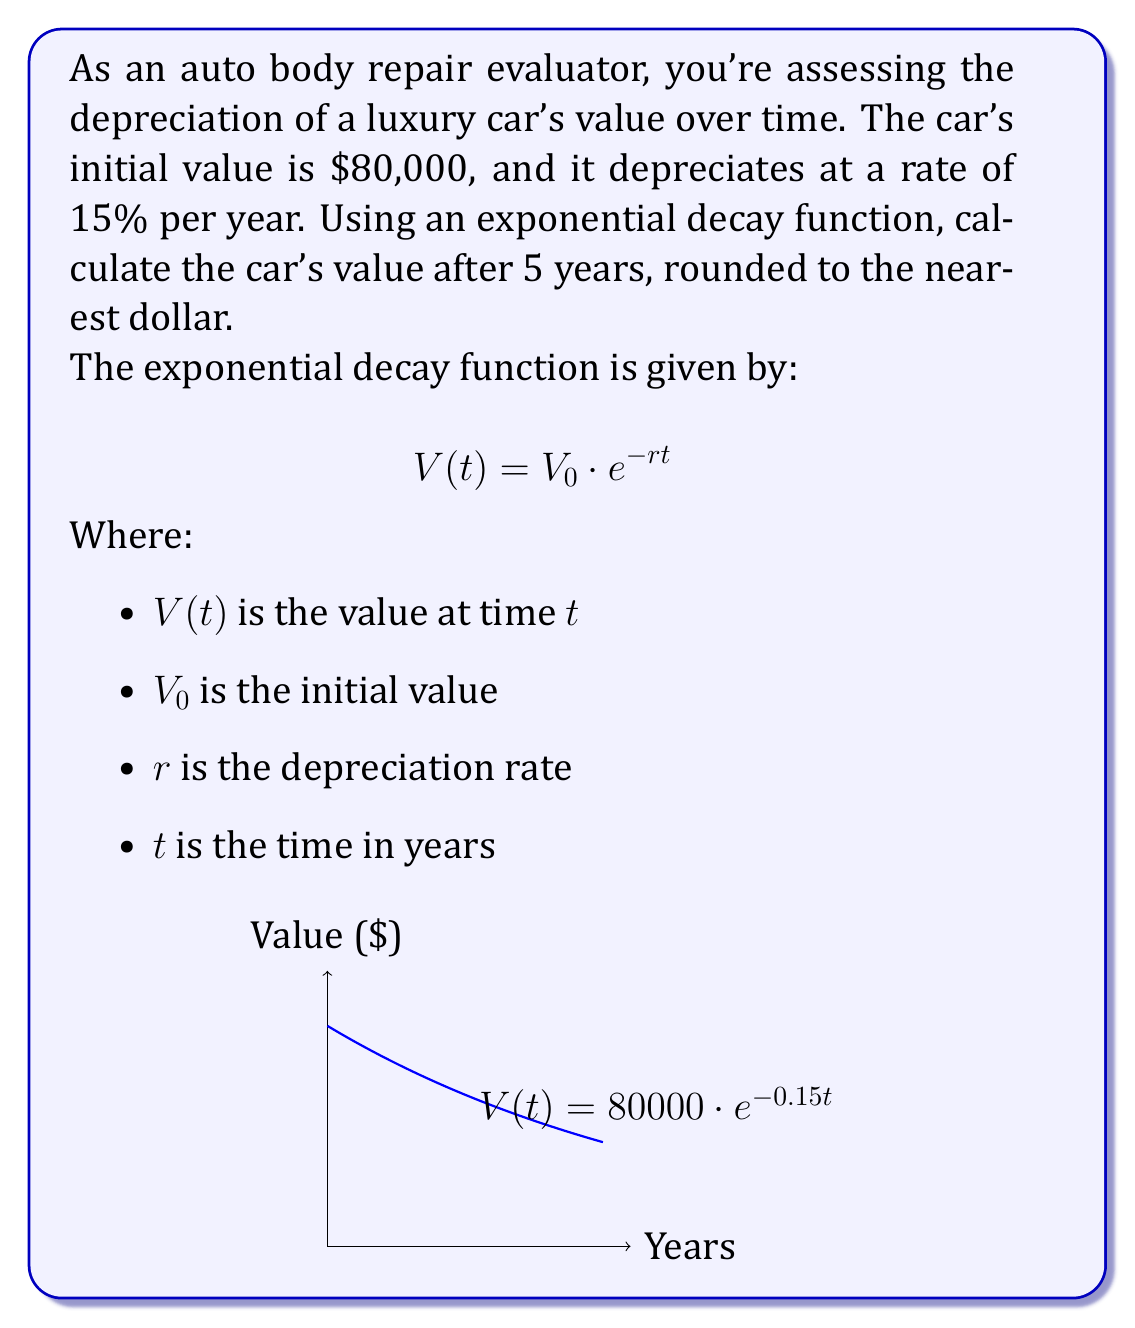Teach me how to tackle this problem. Let's solve this step-by-step:

1) We're given:
   $V_0 = 80000$ (initial value)
   $r = 0.15$ (15% annual depreciation rate)
   $t = 5$ (years)

2) Plug these values into the exponential decay function:
   $$V(5) = 80000 \cdot e^{-0.15 \cdot 5}$$

3) Simplify the exponent:
   $$V(5) = 80000 \cdot e^{-0.75}$$

4) Calculate $e^{-0.75}$ (you can use a calculator for this):
   $$e^{-0.75} \approx 0.4724$$

5) Multiply:
   $$V(5) = 80000 \cdot 0.4724 \approx 37,792$$

6) Round to the nearest dollar:
   $$V(5) \approx 37,792$$

Therefore, after 5 years, the car's value will be approximately $37,792.
Answer: $37,792 